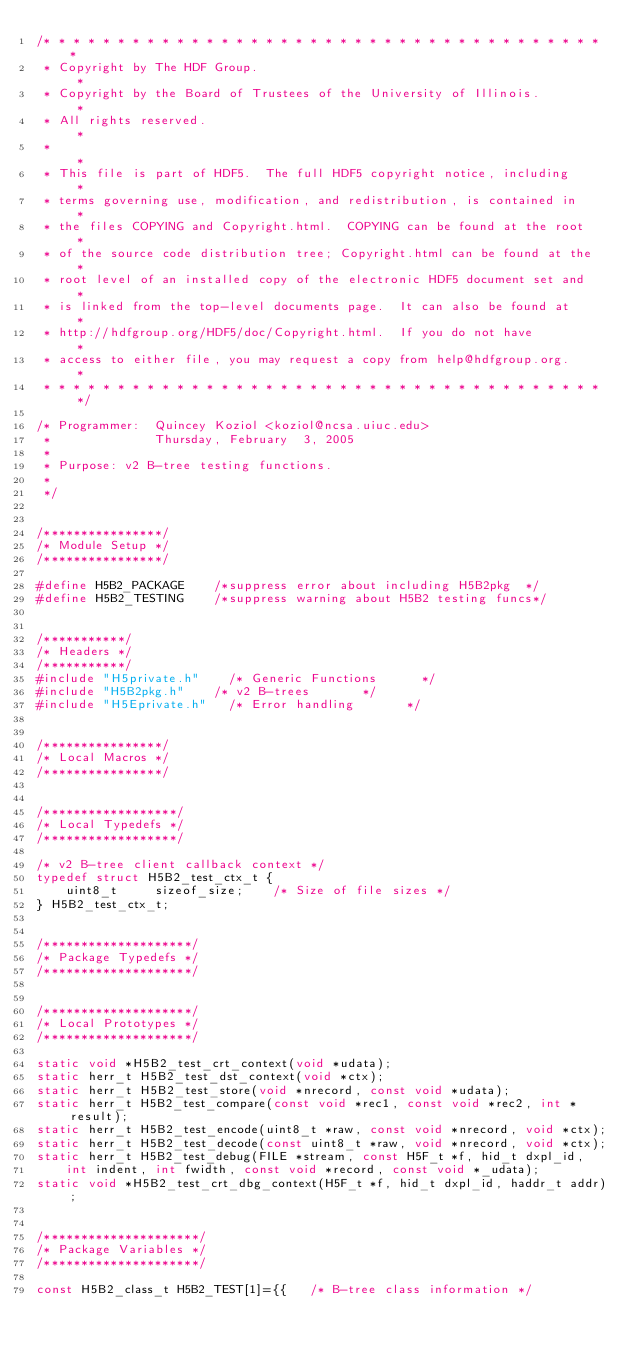Convert code to text. <code><loc_0><loc_0><loc_500><loc_500><_C_>/* * * * * * * * * * * * * * * * * * * * * * * * * * * * * * * * * * * * * * *
 * Copyright by The HDF Group.                                               *
 * Copyright by the Board of Trustees of the University of Illinois.         *
 * All rights reserved.                                                      *
 *                                                                           *
 * This file is part of HDF5.  The full HDF5 copyright notice, including     *
 * terms governing use, modification, and redistribution, is contained in    *
 * the files COPYING and Copyright.html.  COPYING can be found at the root   *
 * of the source code distribution tree; Copyright.html can be found at the  *
 * root level of an installed copy of the electronic HDF5 document set and   *
 * is linked from the top-level documents page.  It can also be found at     *
 * http://hdfgroup.org/HDF5/doc/Copyright.html.  If you do not have          *
 * access to either file, you may request a copy from help@hdfgroup.org.     *
 * * * * * * * * * * * * * * * * * * * * * * * * * * * * * * * * * * * * * * */

/* Programmer:  Quincey Koziol <koziol@ncsa.uiuc.edu>
 *              Thursday, February  3, 2005
 *
 * Purpose:	v2 B-tree testing functions.
 *
 */


/****************/
/* Module Setup */
/****************/

#define H5B2_PACKAGE		/*suppress error about including H5B2pkg  */
#define H5B2_TESTING		/*suppress warning about H5B2 testing funcs*/


/***********/
/* Headers */
/***********/
#include "H5private.h"		/* Generic Functions			*/
#include "H5B2pkg.h"		/* v2 B-trees				*/
#include "H5Eprivate.h"		/* Error handling		  	*/


/****************/
/* Local Macros */
/****************/


/******************/
/* Local Typedefs */
/******************/

/* v2 B-tree client callback context */
typedef struct H5B2_test_ctx_t {
    uint8_t     sizeof_size;    /* Size of file sizes */
} H5B2_test_ctx_t;


/********************/
/* Package Typedefs */
/********************/


/********************/
/* Local Prototypes */
/********************/

static void *H5B2_test_crt_context(void *udata);
static herr_t H5B2_test_dst_context(void *ctx);
static herr_t H5B2_test_store(void *nrecord, const void *udata);
static herr_t H5B2_test_compare(const void *rec1, const void *rec2, int *result);
static herr_t H5B2_test_encode(uint8_t *raw, const void *nrecord, void *ctx);
static herr_t H5B2_test_decode(const uint8_t *raw, void *nrecord, void *ctx);
static herr_t H5B2_test_debug(FILE *stream, const H5F_t *f, hid_t dxpl_id,
    int indent, int fwidth, const void *record, const void *_udata);
static void *H5B2_test_crt_dbg_context(H5F_t *f, hid_t dxpl_id, haddr_t addr);


/*********************/
/* Package Variables */
/*********************/

const H5B2_class_t H5B2_TEST[1]={{   /* B-tree class information */</code> 